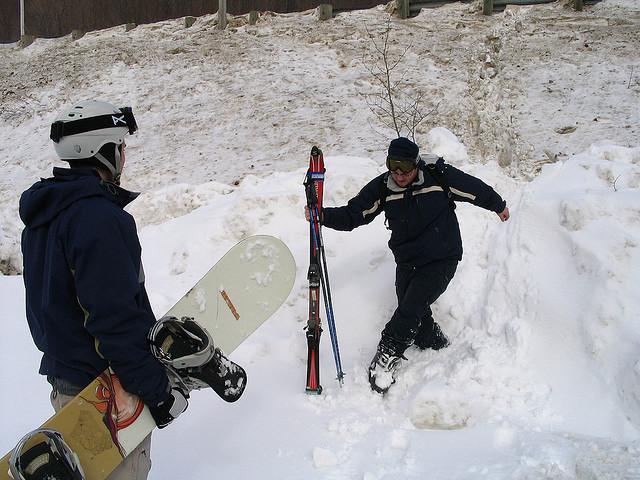Does the man look happy?
Short answer required. Yes. Are both men walking in the snow?
Answer briefly. Yes. Which brand is the snowboard?
Short answer required. None. What color is the snow?
Concise answer only. White. Are they warm enough?
Quick response, please. Yes. 